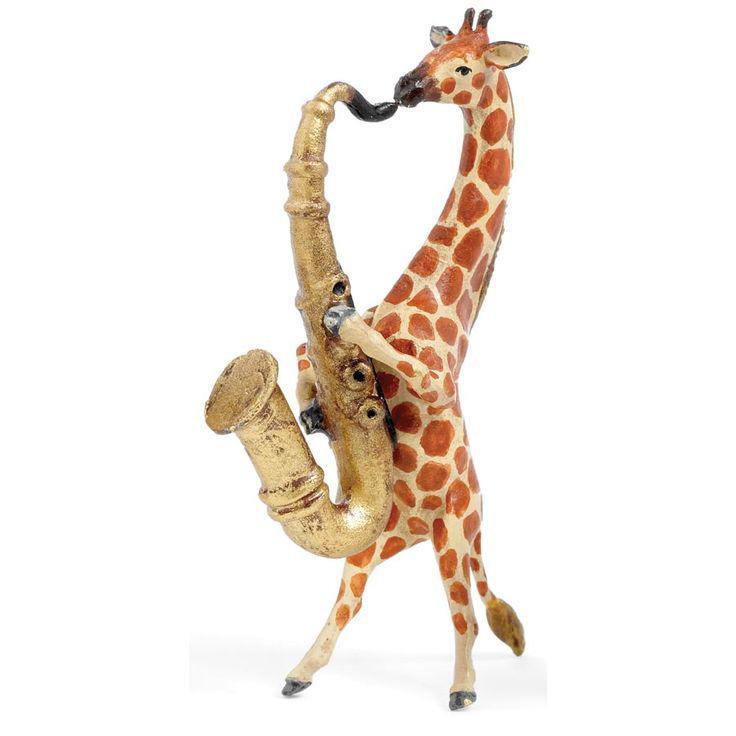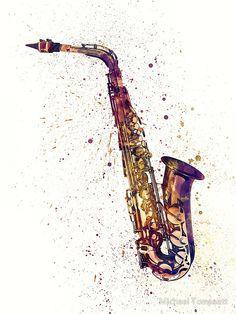The first image is the image on the left, the second image is the image on the right. Considering the images on both sides, is "The sax in the left image is pointed left and the sax in the right image is pointed right." valid? Answer yes or no. Yes. The first image is the image on the left, the second image is the image on the right. Assess this claim about the two images: "In at least one image there is a single saxophone surrounded by purple special dots.". Correct or not? Answer yes or no. Yes. 